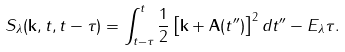<formula> <loc_0><loc_0><loc_500><loc_500>S _ { \lambda } ( \mathbf k , t , t - \tau ) = \int _ { t - \tau } ^ { t } \frac { 1 } { 2 } \left [ \mathbf k + \mathbf A ( t ^ { \prime \prime } ) \right ] ^ { 2 } d t ^ { \prime \prime } - E _ { \lambda } \tau .</formula> 